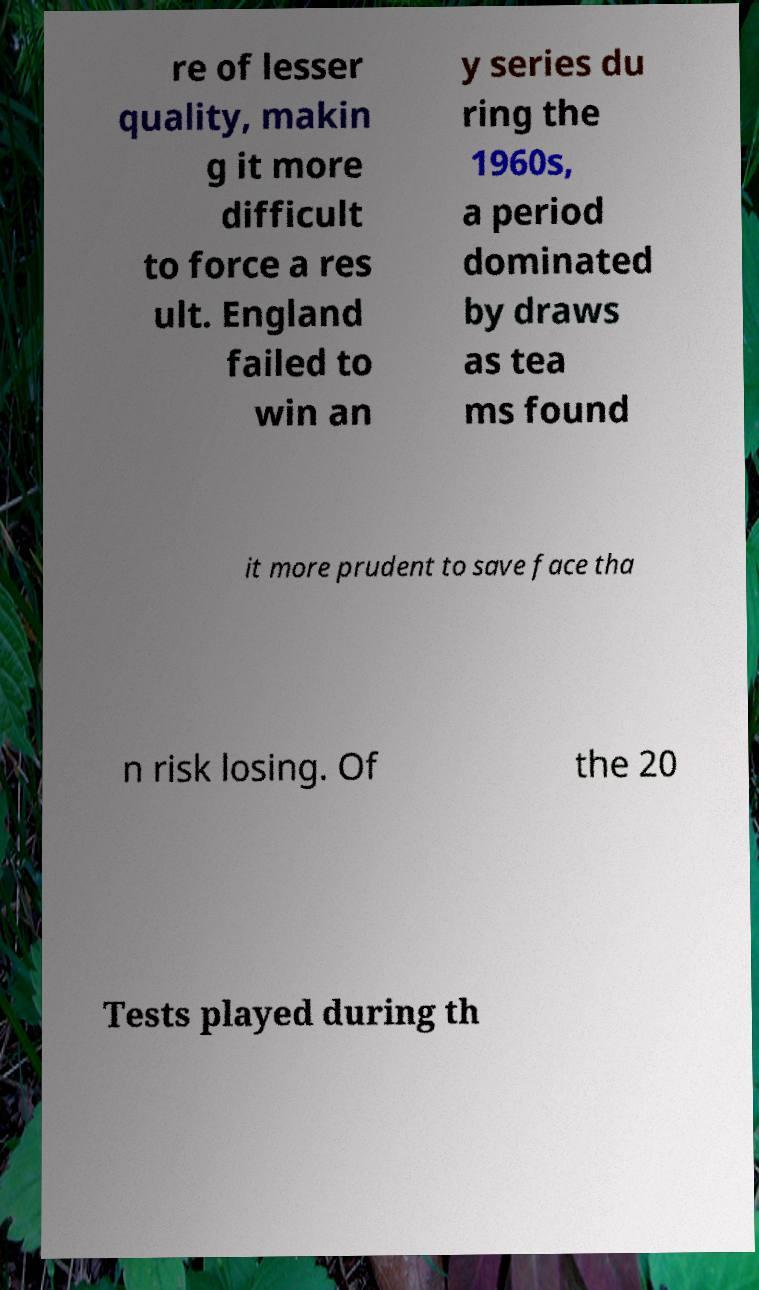There's text embedded in this image that I need extracted. Can you transcribe it verbatim? re of lesser quality, makin g it more difficult to force a res ult. England failed to win an y series du ring the 1960s, a period dominated by draws as tea ms found it more prudent to save face tha n risk losing. Of the 20 Tests played during th 